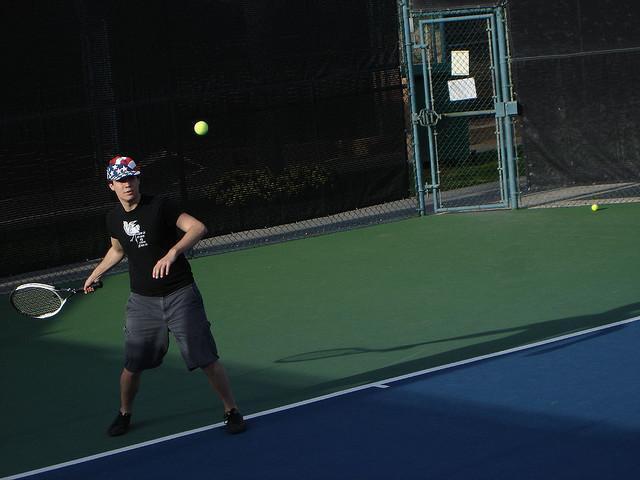Why is their hand held way back?
Select the accurate answer and provide explanation: 'Answer: answer
Rationale: rationale.'
Options: Stop falling, swat mosquito, swing ball, self defense. Answer: swing ball.
Rationale: A man with a tennis racket in hand is reared back as a ball approaches. 